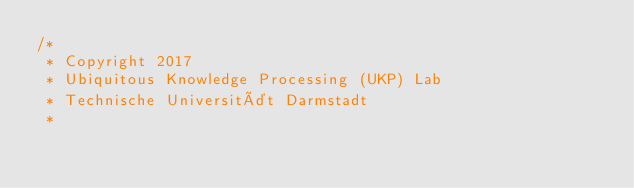Convert code to text. <code><loc_0><loc_0><loc_500><loc_500><_Java_>/*
 * Copyright 2017
 * Ubiquitous Knowledge Processing (UKP) Lab
 * Technische Universität Darmstadt
 *</code> 